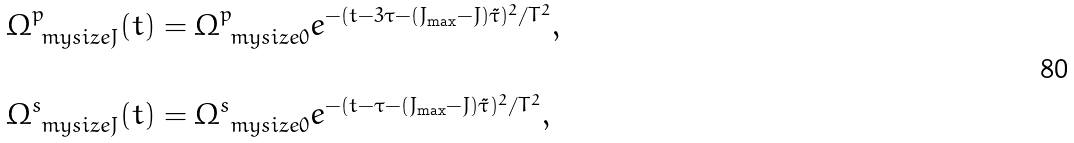Convert formula to latex. <formula><loc_0><loc_0><loc_500><loc_500>& \Omega ^ { p } _ { \ m y s i z e J } ( t ) = \Omega ^ { p } _ { \ m y s i z e 0 } e ^ { - ( t - 3 \tau - ( J _ { \max } - J ) \tilde { \tau } ) ^ { 2 } / T ^ { 2 } } , \\ \\ & \Omega ^ { s } _ { \ m y s i z e J } ( t ) = \Omega ^ { s } _ { \ m y s i z e 0 } e ^ { - ( t - \tau - ( J _ { \max } - J ) \tilde { \tau } ) ^ { 2 } / T ^ { 2 } } ,</formula> 